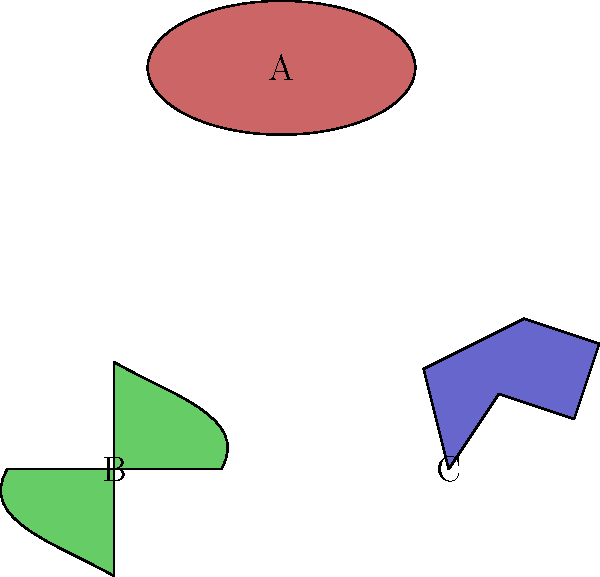In the diagram above, three types of galaxies are represented using simple shapes. Match each shape to its corresponding galaxy type: elliptical, spiral, and irregular. How do these shapes relate to the actual structures observed in these galaxy types? To answer this question, let's analyze each shape and relate it to the characteristics of galaxy types:

1. Shape A (top): This is an ellipse, which represents an elliptical galaxy.
   - Elliptical galaxies are smooth, featureless systems with an ellipsoidal shape.
   - They lack spiral arms and have a uniform distribution of stars.
   - The elliptical shape accurately represents their overall structure.

2. Shape B (bottom left): This spiral-like shape represents a spiral galaxy.
   - Spiral galaxies have a central bulge and spiral arms extending outward.
   - The curved lines in the diagram represent these spiral arms.
   - Spiral arms contain younger stars, gas, and dust, while the central bulge consists of older stars.

3. Shape C (bottom right): This irregular shape represents an irregular galaxy.
   - Irregular galaxies lack a defined structure or symmetry.
   - They don't fit into the elliptical or spiral categories.
   - The asymmetrical shape in the diagram reflects their chaotic nature.

These simplified shapes capture the essence of each galaxy type:
- Elliptical galaxies: smooth, ellipsoidal structure
- Spiral galaxies: central bulge with extending spiral arms
- Irregular galaxies: lack of definite structure or symmetry

While these representations are simplified, they provide a good starting point for understanding the basic structural differences between galaxy types. In reality, galaxies are much more complex, with variations within each type and transitional forms between types.
Answer: A: Elliptical, B: Spiral, C: Irregular 